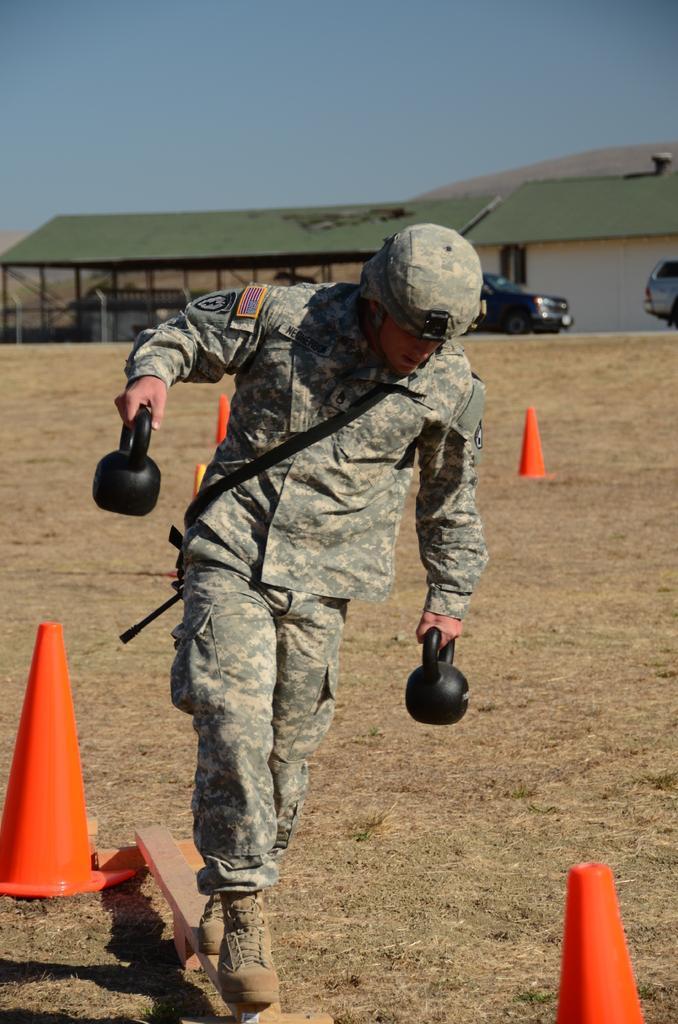Can you describe this image briefly? In this picture I can see there is a man walking on the wooden plank and he is holding weights, there are few traffic cones on the floor. In the backdrop, there are few cars parked, there is a building in the backdrop and the sky is clear. 